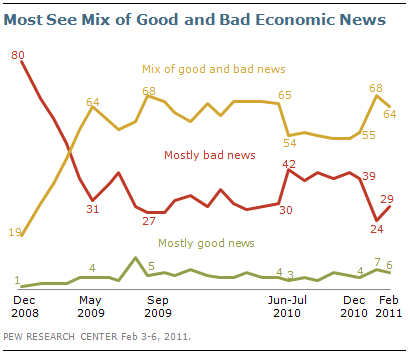Can you identify any trends related to the 'Mix of good and bad news' category? Yes, examining the 'Mix of good and bad news' category, we notice a significant increase from December 2008 to May 2009, after which it experiences moments of decline and ascent but maintains a dominant position compared to the other two categories. This overall trend suggests that despite the fluctuations in 'Mostly good news' and 'Mostly bad news', a consistent majority perceived economic news as a blend of both, indicating perhaps a more nuanced public understanding of economic conditions. 